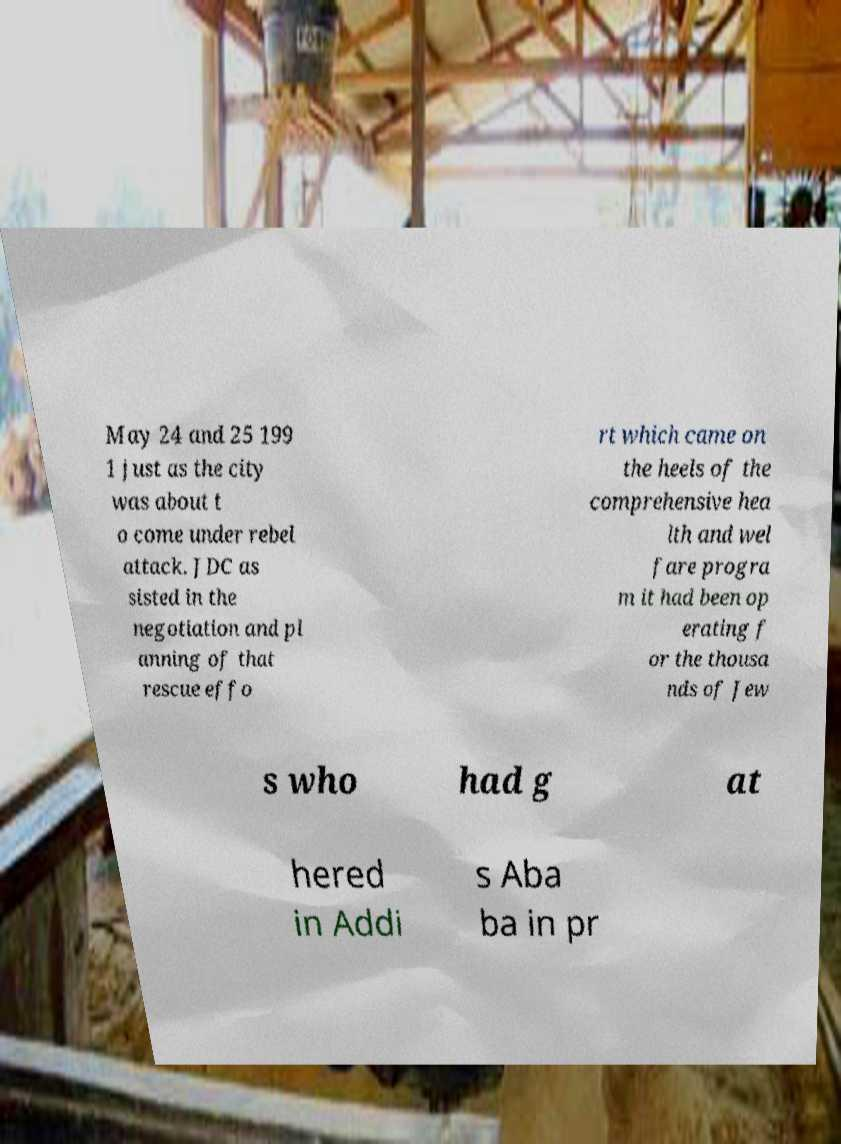I need the written content from this picture converted into text. Can you do that? May 24 and 25 199 1 just as the city was about t o come under rebel attack. JDC as sisted in the negotiation and pl anning of that rescue effo rt which came on the heels of the comprehensive hea lth and wel fare progra m it had been op erating f or the thousa nds of Jew s who had g at hered in Addi s Aba ba in pr 